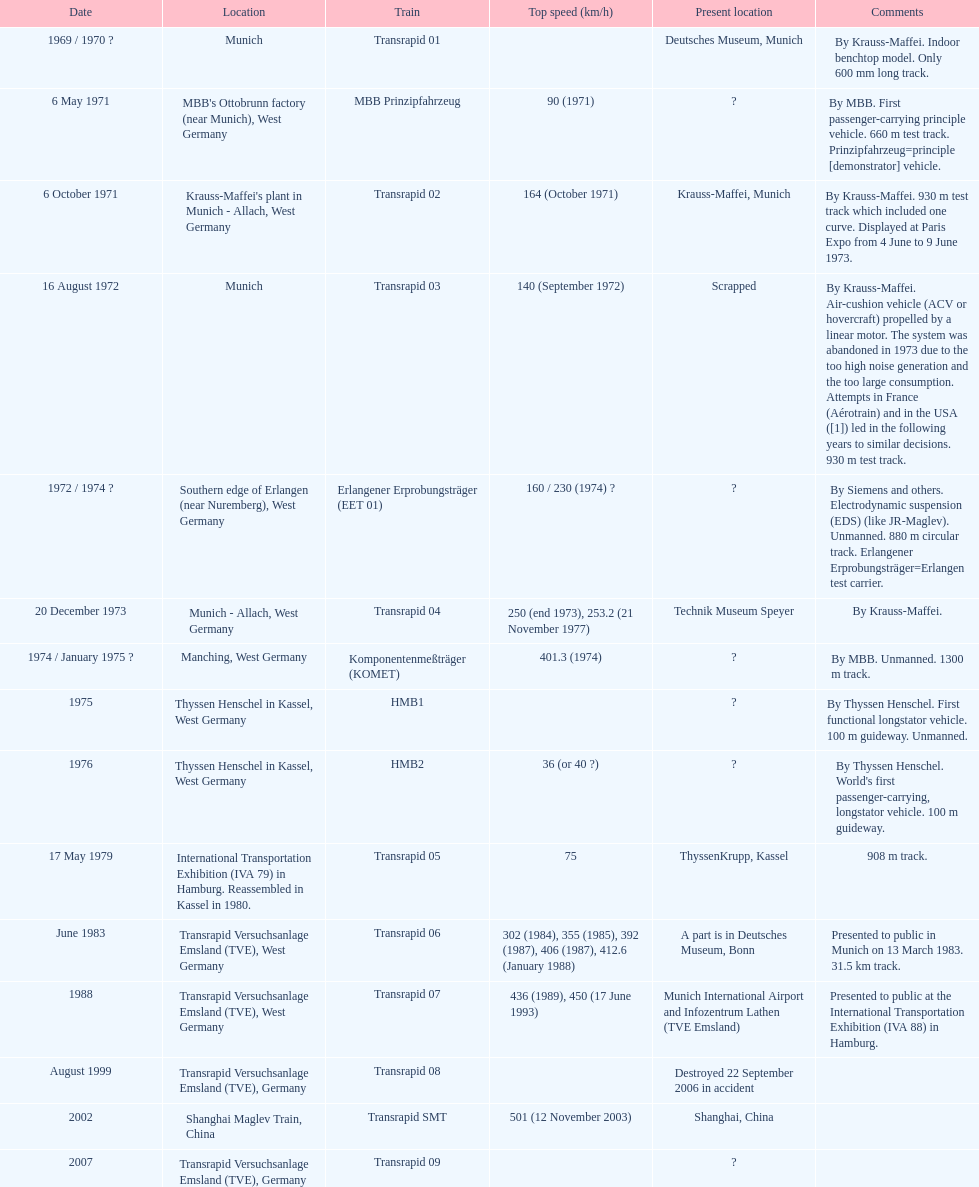What is the only train to reach a top speed of 500 or more? Transrapid SMT. Would you mind parsing the complete table? {'header': ['Date', 'Location', 'Train', 'Top speed (km/h)', 'Present location', 'Comments'], 'rows': [['1969 / 1970\xa0?', 'Munich', 'Transrapid 01', '', 'Deutsches Museum, Munich', 'By Krauss-Maffei. Indoor benchtop model. Only 600\xa0mm long track.'], ['6 May 1971', "MBB's Ottobrunn factory (near Munich), West Germany", 'MBB Prinzipfahrzeug', '90 (1971)', '?', 'By MBB. First passenger-carrying principle vehicle. 660 m test track. Prinzipfahrzeug=principle [demonstrator] vehicle.'], ['6 October 1971', "Krauss-Maffei's plant in Munich - Allach, West Germany", 'Transrapid 02', '164 (October 1971)', 'Krauss-Maffei, Munich', 'By Krauss-Maffei. 930 m test track which included one curve. Displayed at Paris Expo from 4 June to 9 June 1973.'], ['16 August 1972', 'Munich', 'Transrapid 03', '140 (September 1972)', 'Scrapped', 'By Krauss-Maffei. Air-cushion vehicle (ACV or hovercraft) propelled by a linear motor. The system was abandoned in 1973 due to the too high noise generation and the too large consumption. Attempts in France (Aérotrain) and in the USA ([1]) led in the following years to similar decisions. 930 m test track.'], ['1972 / 1974\xa0?', 'Southern edge of Erlangen (near Nuremberg), West Germany', 'Erlangener Erprobungsträger (EET 01)', '160 / 230 (1974)\xa0?', '?', 'By Siemens and others. Electrodynamic suspension (EDS) (like JR-Maglev). Unmanned. 880 m circular track. Erlangener Erprobungsträger=Erlangen test carrier.'], ['20 December 1973', 'Munich - Allach, West Germany', 'Transrapid 04', '250 (end 1973), 253.2 (21 November 1977)', 'Technik Museum Speyer', 'By Krauss-Maffei.'], ['1974 / January 1975\xa0?', 'Manching, West Germany', 'Komponentenmeßträger (KOMET)', '401.3 (1974)', '?', 'By MBB. Unmanned. 1300 m track.'], ['1975', 'Thyssen Henschel in Kassel, West Germany', 'HMB1', '', '?', 'By Thyssen Henschel. First functional longstator vehicle. 100 m guideway. Unmanned.'], ['1976', 'Thyssen Henschel in Kassel, West Germany', 'HMB2', '36 (or 40\xa0?)', '?', "By Thyssen Henschel. World's first passenger-carrying, longstator vehicle. 100 m guideway."], ['17 May 1979', 'International Transportation Exhibition (IVA 79) in Hamburg. Reassembled in Kassel in 1980.', 'Transrapid 05', '75', 'ThyssenKrupp, Kassel', '908 m track.'], ['June 1983', 'Transrapid Versuchsanlage Emsland (TVE), West Germany', 'Transrapid 06', '302 (1984), 355 (1985), 392 (1987), 406 (1987), 412.6 (January 1988)', 'A part is in Deutsches Museum, Bonn', 'Presented to public in Munich on 13 March 1983. 31.5\xa0km track.'], ['1988', 'Transrapid Versuchsanlage Emsland (TVE), West Germany', 'Transrapid 07', '436 (1989), 450 (17 June 1993)', 'Munich International Airport and Infozentrum Lathen (TVE Emsland)', 'Presented to public at the International Transportation Exhibition (IVA 88) in Hamburg.'], ['August 1999', 'Transrapid Versuchsanlage Emsland (TVE), Germany', 'Transrapid 08', '', 'Destroyed 22 September 2006 in accident', ''], ['2002', 'Shanghai Maglev Train, China', 'Transrapid SMT', '501 (12 November 2003)', 'Shanghai, China', ''], ['2007', 'Transrapid Versuchsanlage Emsland (TVE), Germany', 'Transrapid 09', '', '?', '']]} 